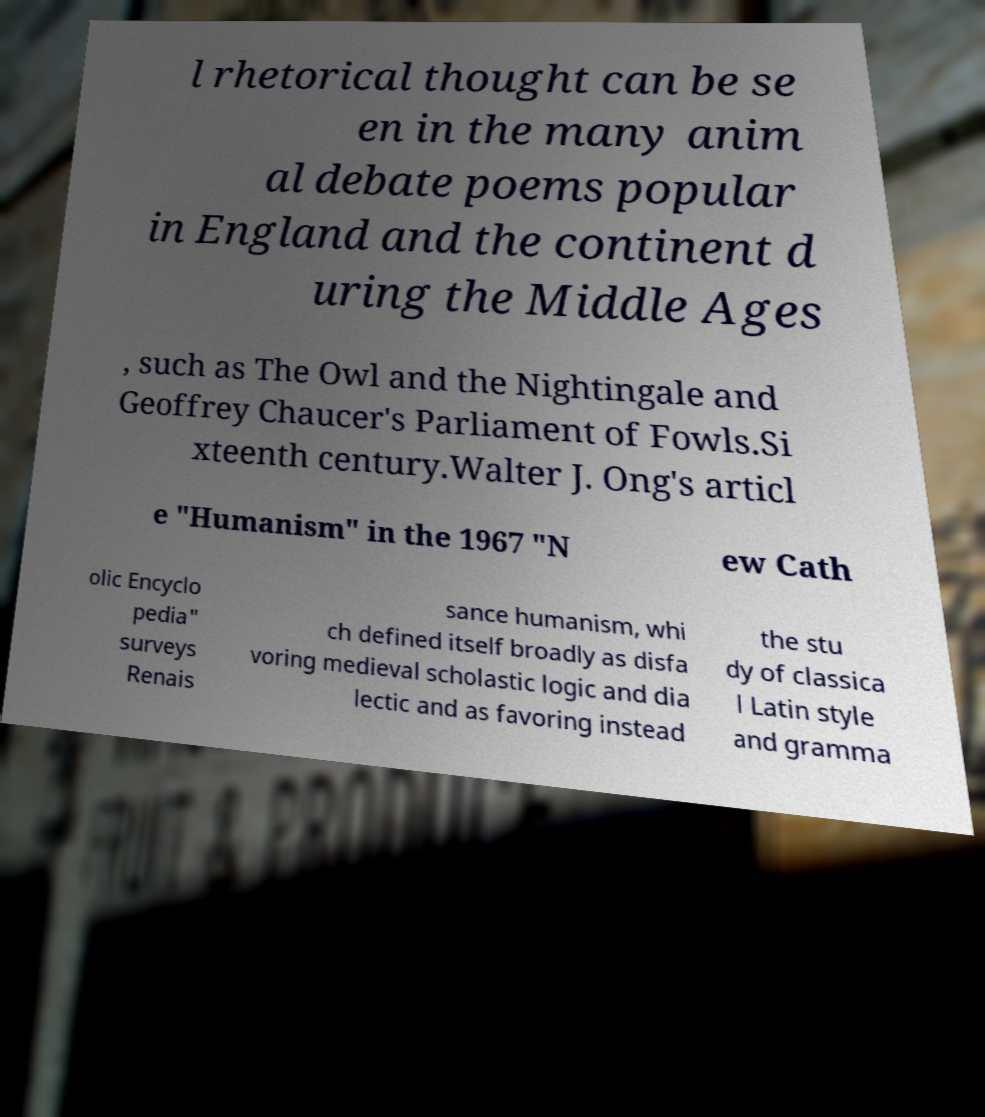Could you extract and type out the text from this image? l rhetorical thought can be se en in the many anim al debate poems popular in England and the continent d uring the Middle Ages , such as The Owl and the Nightingale and Geoffrey Chaucer's Parliament of Fowls.Si xteenth century.Walter J. Ong's articl e "Humanism" in the 1967 "N ew Cath olic Encyclo pedia" surveys Renais sance humanism, whi ch defined itself broadly as disfa voring medieval scholastic logic and dia lectic and as favoring instead the stu dy of classica l Latin style and gramma 